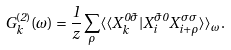Convert formula to latex. <formula><loc_0><loc_0><loc_500><loc_500>G _ { k } ^ { ( 2 ) } ( \omega ) = \frac { 1 } { z } \sum _ { \rho } \langle \langle X _ { k } ^ { 0 \tilde { \sigma } } | X _ { i } ^ { \tilde { \sigma } 0 } X _ { i + \rho } ^ { \sigma \sigma } \rangle \rangle _ { \omega } .</formula> 